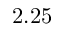<formula> <loc_0><loc_0><loc_500><loc_500>2 . 2 5</formula> 